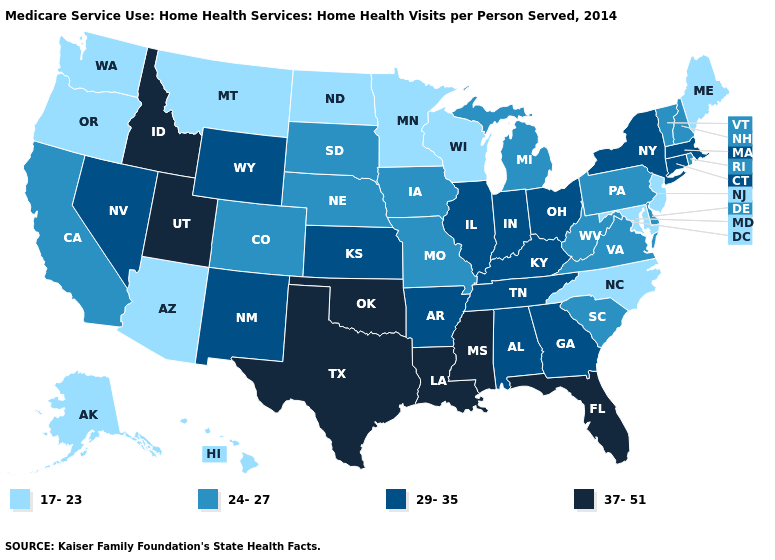Does New Jersey have the highest value in the USA?
Answer briefly. No. What is the value of Michigan?
Answer briefly. 24-27. Does West Virginia have a lower value than Louisiana?
Quick response, please. Yes. Does Vermont have the highest value in the Northeast?
Concise answer only. No. What is the value of South Dakota?
Be succinct. 24-27. Which states have the highest value in the USA?
Be succinct. Florida, Idaho, Louisiana, Mississippi, Oklahoma, Texas, Utah. Among the states that border South Carolina , does Georgia have the highest value?
Give a very brief answer. Yes. What is the lowest value in the MidWest?
Quick response, please. 17-23. Name the states that have a value in the range 17-23?
Answer briefly. Alaska, Arizona, Hawaii, Maine, Maryland, Minnesota, Montana, New Jersey, North Carolina, North Dakota, Oregon, Washington, Wisconsin. What is the highest value in the South ?
Answer briefly. 37-51. What is the value of Arizona?
Quick response, please. 17-23. What is the highest value in the USA?
Quick response, please. 37-51. Among the states that border Kansas , which have the lowest value?
Answer briefly. Colorado, Missouri, Nebraska. Which states hav the highest value in the Northeast?
Give a very brief answer. Connecticut, Massachusetts, New York. What is the lowest value in the West?
Quick response, please. 17-23. 